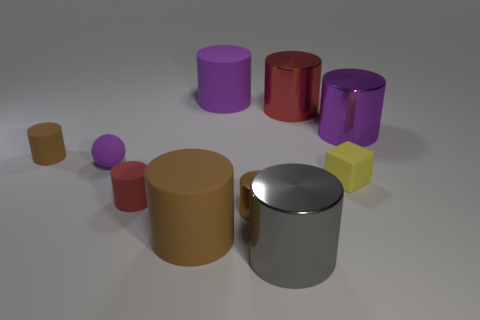Subtract all purple balls. How many brown cylinders are left? 3 Subtract all brown cylinders. How many cylinders are left? 5 Subtract all large red metallic cylinders. How many cylinders are left? 7 Subtract all green cylinders. Subtract all cyan blocks. How many cylinders are left? 8 Subtract all balls. How many objects are left? 9 Subtract 0 brown blocks. How many objects are left? 10 Subtract all yellow matte blocks. Subtract all spheres. How many objects are left? 8 Add 7 big red things. How many big red things are left? 8 Add 6 big gray things. How many big gray things exist? 7 